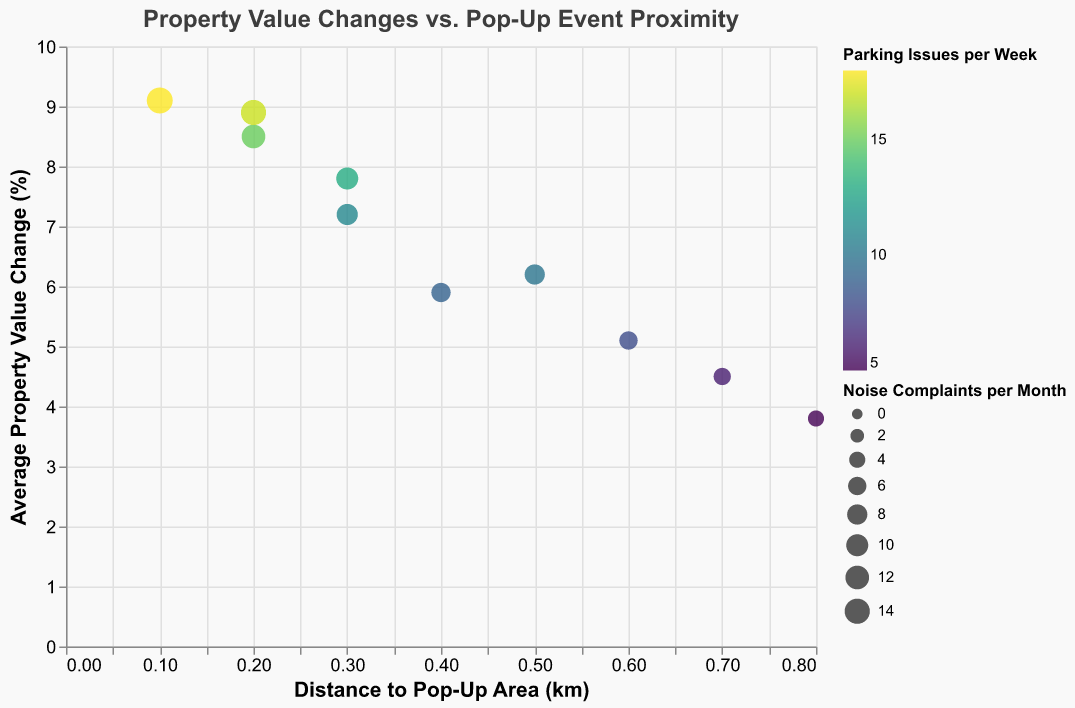What is the average property value change in Williamsburg? To find this, look at the value on the y-axis corresponding to Williamsburg in the figure. The y-axis represents the average property value change percentage.
Answer: 8.5% Which neighborhood has the highest number of noise complaints per month? Compare the size of the circles, as the size encodes the noise complaints per month. The largest circle represents the neighborhood with the highest number of complaints. Bushwick has the largest circle.
Answer: Bushwick How does the parking issue frequency in Park Slope compare to that in DUMBO? To compare, look at the color gradient since color encodes parking issues per week. Park Slope (10) has a slightly lighter color than DUMBO (13), indicating fewer parking issues per week.
Answer: Fewer in Park Slope What is the relationship between distance to pop-up areas and property value change? Observe the trend in the scatter plot. As the distance increases along the x-axis, the average property value change drop follows a decreasing trend along the y-axis.
Answer: Negative correlation Which neighborhood is closest to the pop-up event area but has relatively low property value change? Find the data point with the smallest x-value for distance that has the lowest y-value for property value change. Greenpoint is close to the pop-up area (0.4 km) with a lower property value change percentage (5.9%).
Answer: Greenpoint How many neighborhoods have noise complaints exceeding 10 per month? Count the number of circles with a size that represents noise complaints higher than 10. There are Williamsberg, Bushwick, and East Village.
Answer: 3 neighborhoods Which neighborhood shows the highest average property value change? Check the y-axis values to find the highest point. Bushwick has the highest average property value change of 9.1%.
Answer: Bushwick Is there any neighborhood where the property value change exceeds 8% but has less than 10 parking issues weekly? Look for points above the 8% mark on the y-axis and check their color gradient for lower parking issues. Williamsburg fits this criteria perfectly.
Answer: Williamsburg 